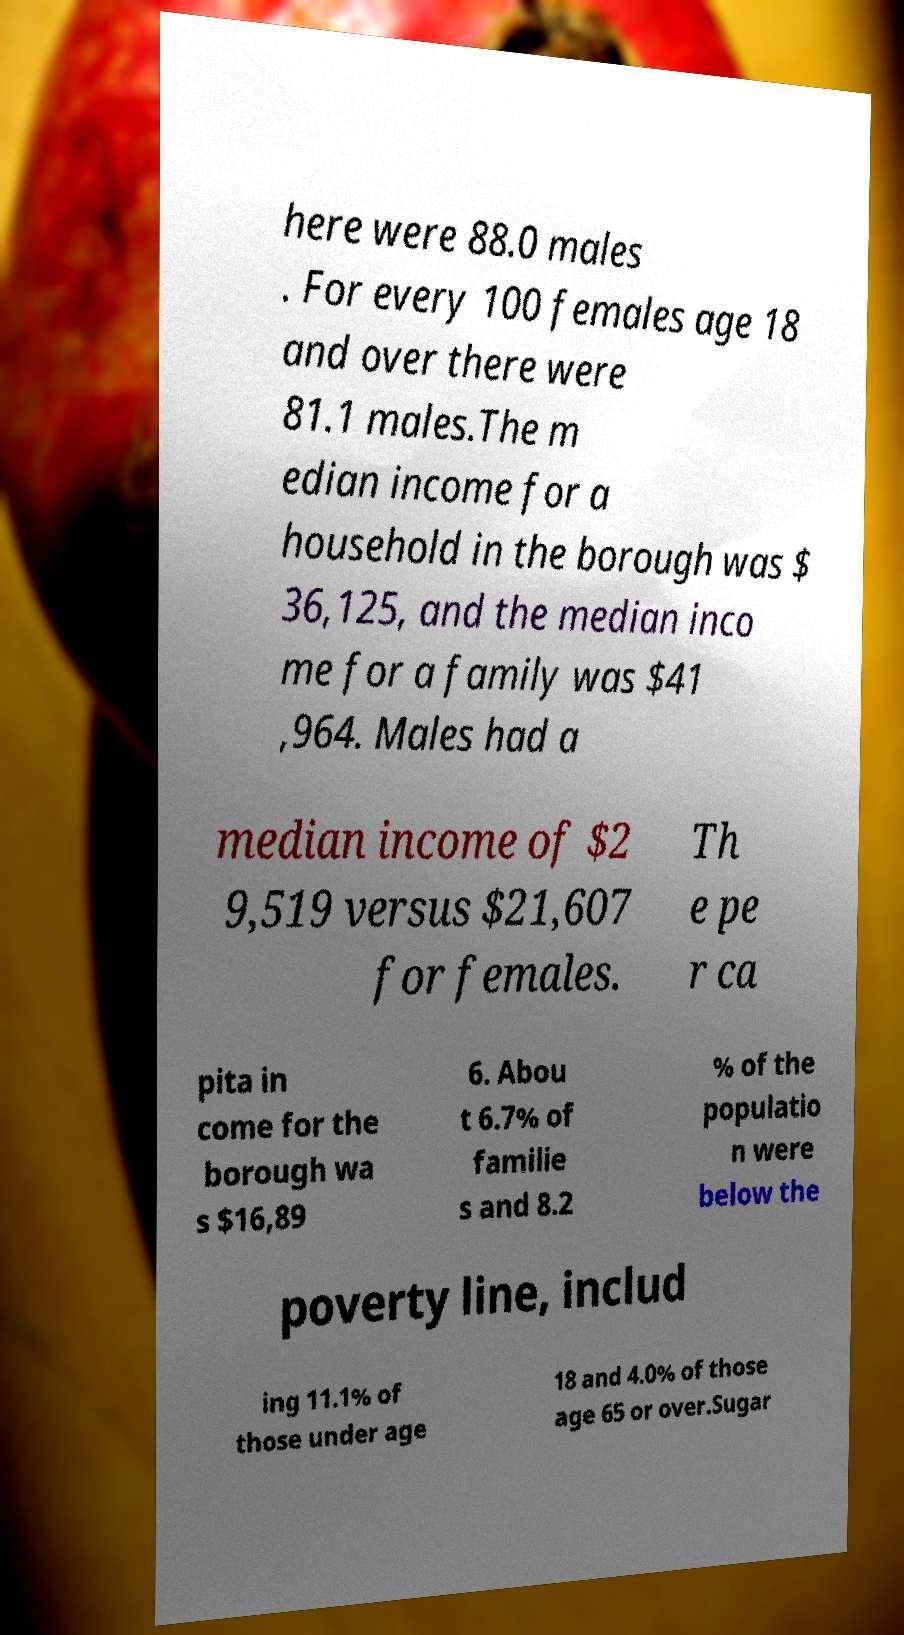Could you assist in decoding the text presented in this image and type it out clearly? here were 88.0 males . For every 100 females age 18 and over there were 81.1 males.The m edian income for a household in the borough was $ 36,125, and the median inco me for a family was $41 ,964. Males had a median income of $2 9,519 versus $21,607 for females. Th e pe r ca pita in come for the borough wa s $16,89 6. Abou t 6.7% of familie s and 8.2 % of the populatio n were below the poverty line, includ ing 11.1% of those under age 18 and 4.0% of those age 65 or over.Sugar 